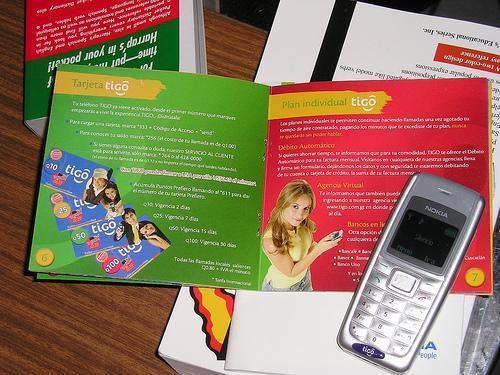How many cellphones are there?
Give a very brief answer. 1. How many people are in the picture?
Give a very brief answer. 1. How many books can be seen?
Give a very brief answer. 3. 